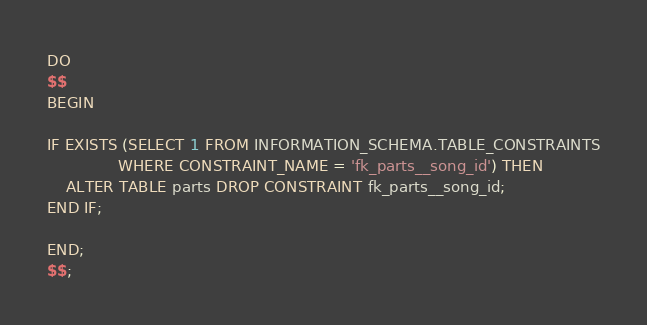Convert code to text. <code><loc_0><loc_0><loc_500><loc_500><_SQL_>DO
$$
BEGIN

IF EXISTS (SELECT 1 FROM INFORMATION_SCHEMA.TABLE_CONSTRAINTS
               WHERE CONSTRAINT_NAME = 'fk_parts__song_id') THEN
    ALTER TABLE parts DROP CONSTRAINT fk_parts__song_id;
END IF;

END;
$$;</code> 